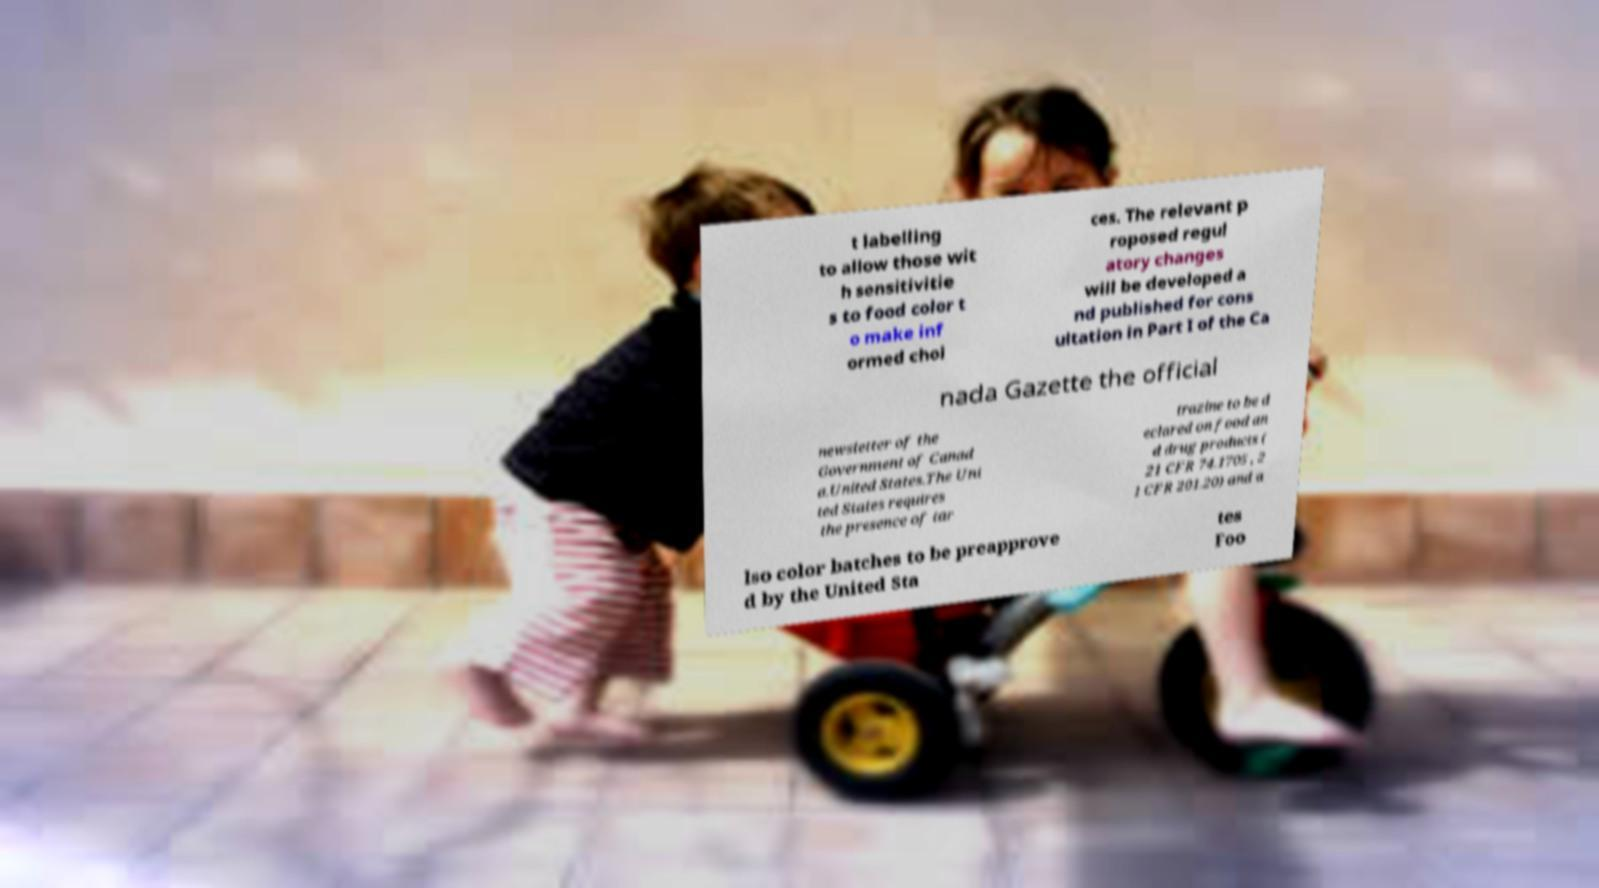There's text embedded in this image that I need extracted. Can you transcribe it verbatim? t labelling to allow those wit h sensitivitie s to food color t o make inf ormed choi ces. The relevant p roposed regul atory changes will be developed a nd published for cons ultation in Part I of the Ca nada Gazette the official newsletter of the Government of Canad a.United States.The Uni ted States requires the presence of tar trazine to be d eclared on food an d drug products ( 21 CFR 74.1705 , 2 1 CFR 201.20) and a lso color batches to be preapprove d by the United Sta tes Foo 